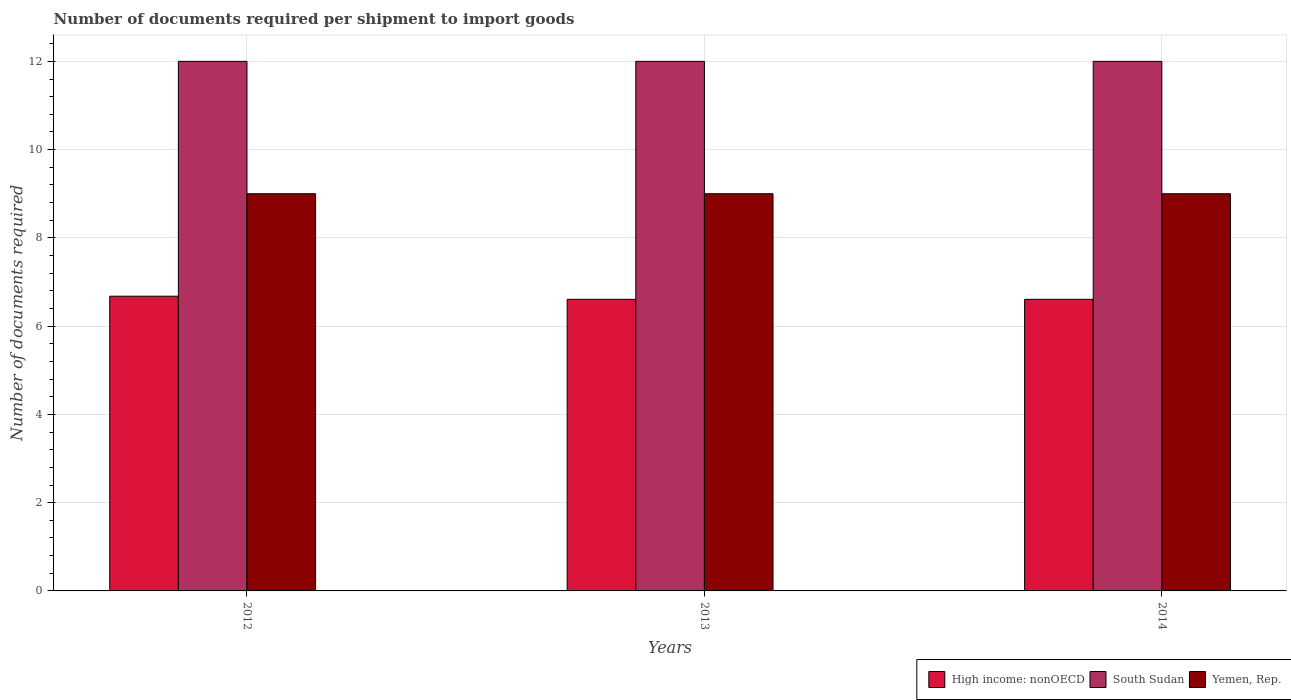Are the number of bars on each tick of the X-axis equal?
Provide a succinct answer. Yes. How many bars are there on the 3rd tick from the right?
Provide a short and direct response. 3. What is the label of the 3rd group of bars from the left?
Keep it short and to the point. 2014. What is the number of documents required per shipment to import goods in Yemen, Rep. in 2013?
Provide a short and direct response. 9. Across all years, what is the maximum number of documents required per shipment to import goods in Yemen, Rep.?
Ensure brevity in your answer.  9. Across all years, what is the minimum number of documents required per shipment to import goods in South Sudan?
Ensure brevity in your answer.  12. In which year was the number of documents required per shipment to import goods in High income: nonOECD maximum?
Ensure brevity in your answer.  2012. In which year was the number of documents required per shipment to import goods in High income: nonOECD minimum?
Offer a terse response. 2013. What is the total number of documents required per shipment to import goods in High income: nonOECD in the graph?
Keep it short and to the point. 19.89. What is the difference between the number of documents required per shipment to import goods in High income: nonOECD in 2012 and that in 2013?
Provide a short and direct response. 0.07. What is the difference between the number of documents required per shipment to import goods in High income: nonOECD in 2014 and the number of documents required per shipment to import goods in Yemen, Rep. in 2013?
Keep it short and to the point. -2.39. In the year 2012, what is the difference between the number of documents required per shipment to import goods in Yemen, Rep. and number of documents required per shipment to import goods in High income: nonOECD?
Ensure brevity in your answer.  2.32. In how many years, is the number of documents required per shipment to import goods in Yemen, Rep. greater than 5.2?
Provide a succinct answer. 3. What is the ratio of the number of documents required per shipment to import goods in Yemen, Rep. in 2012 to that in 2014?
Your answer should be very brief. 1. Is the number of documents required per shipment to import goods in Yemen, Rep. in 2012 less than that in 2014?
Your answer should be very brief. No. Is the difference between the number of documents required per shipment to import goods in Yemen, Rep. in 2012 and 2013 greater than the difference between the number of documents required per shipment to import goods in High income: nonOECD in 2012 and 2013?
Make the answer very short. No. What is the difference between the highest and the second highest number of documents required per shipment to import goods in South Sudan?
Keep it short and to the point. 0. What does the 1st bar from the left in 2012 represents?
Keep it short and to the point. High income: nonOECD. What does the 1st bar from the right in 2014 represents?
Offer a very short reply. Yemen, Rep. Is it the case that in every year, the sum of the number of documents required per shipment to import goods in South Sudan and number of documents required per shipment to import goods in Yemen, Rep. is greater than the number of documents required per shipment to import goods in High income: nonOECD?
Your response must be concise. Yes. What is the difference between two consecutive major ticks on the Y-axis?
Provide a short and direct response. 2. What is the title of the graph?
Provide a succinct answer. Number of documents required per shipment to import goods. What is the label or title of the X-axis?
Offer a very short reply. Years. What is the label or title of the Y-axis?
Provide a succinct answer. Number of documents required. What is the Number of documents required in High income: nonOECD in 2012?
Offer a very short reply. 6.68. What is the Number of documents required of South Sudan in 2012?
Your answer should be compact. 12. What is the Number of documents required of Yemen, Rep. in 2012?
Give a very brief answer. 9. What is the Number of documents required of High income: nonOECD in 2013?
Ensure brevity in your answer.  6.61. What is the Number of documents required in High income: nonOECD in 2014?
Give a very brief answer. 6.61. What is the Number of documents required of South Sudan in 2014?
Keep it short and to the point. 12. What is the Number of documents required in Yemen, Rep. in 2014?
Offer a very short reply. 9. Across all years, what is the maximum Number of documents required in High income: nonOECD?
Provide a succinct answer. 6.68. Across all years, what is the maximum Number of documents required in Yemen, Rep.?
Keep it short and to the point. 9. Across all years, what is the minimum Number of documents required in High income: nonOECD?
Offer a terse response. 6.61. Across all years, what is the minimum Number of documents required of South Sudan?
Keep it short and to the point. 12. What is the total Number of documents required of High income: nonOECD in the graph?
Keep it short and to the point. 19.89. What is the total Number of documents required in Yemen, Rep. in the graph?
Make the answer very short. 27. What is the difference between the Number of documents required in High income: nonOECD in 2012 and that in 2013?
Keep it short and to the point. 0.07. What is the difference between the Number of documents required of South Sudan in 2012 and that in 2013?
Your answer should be compact. 0. What is the difference between the Number of documents required in High income: nonOECD in 2012 and that in 2014?
Keep it short and to the point. 0.07. What is the difference between the Number of documents required of Yemen, Rep. in 2012 and that in 2014?
Give a very brief answer. 0. What is the difference between the Number of documents required in Yemen, Rep. in 2013 and that in 2014?
Keep it short and to the point. 0. What is the difference between the Number of documents required of High income: nonOECD in 2012 and the Number of documents required of South Sudan in 2013?
Provide a short and direct response. -5.32. What is the difference between the Number of documents required in High income: nonOECD in 2012 and the Number of documents required in Yemen, Rep. in 2013?
Your answer should be compact. -2.32. What is the difference between the Number of documents required of South Sudan in 2012 and the Number of documents required of Yemen, Rep. in 2013?
Your answer should be compact. 3. What is the difference between the Number of documents required of High income: nonOECD in 2012 and the Number of documents required of South Sudan in 2014?
Your answer should be compact. -5.32. What is the difference between the Number of documents required of High income: nonOECD in 2012 and the Number of documents required of Yemen, Rep. in 2014?
Make the answer very short. -2.32. What is the difference between the Number of documents required in South Sudan in 2012 and the Number of documents required in Yemen, Rep. in 2014?
Offer a very short reply. 3. What is the difference between the Number of documents required of High income: nonOECD in 2013 and the Number of documents required of South Sudan in 2014?
Provide a succinct answer. -5.39. What is the difference between the Number of documents required of High income: nonOECD in 2013 and the Number of documents required of Yemen, Rep. in 2014?
Keep it short and to the point. -2.39. What is the average Number of documents required in High income: nonOECD per year?
Provide a succinct answer. 6.63. What is the average Number of documents required of Yemen, Rep. per year?
Your response must be concise. 9. In the year 2012, what is the difference between the Number of documents required in High income: nonOECD and Number of documents required in South Sudan?
Provide a short and direct response. -5.32. In the year 2012, what is the difference between the Number of documents required of High income: nonOECD and Number of documents required of Yemen, Rep.?
Your response must be concise. -2.32. In the year 2012, what is the difference between the Number of documents required in South Sudan and Number of documents required in Yemen, Rep.?
Offer a very short reply. 3. In the year 2013, what is the difference between the Number of documents required of High income: nonOECD and Number of documents required of South Sudan?
Provide a short and direct response. -5.39. In the year 2013, what is the difference between the Number of documents required of High income: nonOECD and Number of documents required of Yemen, Rep.?
Ensure brevity in your answer.  -2.39. In the year 2013, what is the difference between the Number of documents required in South Sudan and Number of documents required in Yemen, Rep.?
Provide a short and direct response. 3. In the year 2014, what is the difference between the Number of documents required of High income: nonOECD and Number of documents required of South Sudan?
Make the answer very short. -5.39. In the year 2014, what is the difference between the Number of documents required in High income: nonOECD and Number of documents required in Yemen, Rep.?
Provide a short and direct response. -2.39. What is the ratio of the Number of documents required of High income: nonOECD in 2012 to that in 2013?
Ensure brevity in your answer.  1.01. What is the ratio of the Number of documents required of South Sudan in 2012 to that in 2013?
Offer a very short reply. 1. What is the ratio of the Number of documents required of High income: nonOECD in 2012 to that in 2014?
Give a very brief answer. 1.01. What is the ratio of the Number of documents required of South Sudan in 2012 to that in 2014?
Provide a short and direct response. 1. What is the ratio of the Number of documents required of Yemen, Rep. in 2012 to that in 2014?
Your answer should be very brief. 1. What is the ratio of the Number of documents required in High income: nonOECD in 2013 to that in 2014?
Offer a terse response. 1. What is the ratio of the Number of documents required of South Sudan in 2013 to that in 2014?
Your answer should be very brief. 1. What is the ratio of the Number of documents required in Yemen, Rep. in 2013 to that in 2014?
Your response must be concise. 1. What is the difference between the highest and the second highest Number of documents required of High income: nonOECD?
Make the answer very short. 0.07. What is the difference between the highest and the second highest Number of documents required in Yemen, Rep.?
Provide a short and direct response. 0. What is the difference between the highest and the lowest Number of documents required in High income: nonOECD?
Give a very brief answer. 0.07. What is the difference between the highest and the lowest Number of documents required of South Sudan?
Make the answer very short. 0. What is the difference between the highest and the lowest Number of documents required in Yemen, Rep.?
Your response must be concise. 0. 